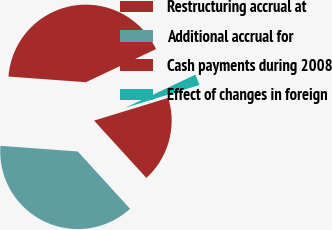Convert chart. <chart><loc_0><loc_0><loc_500><loc_500><pie_chart><fcel>Restructuring accrual at<fcel>Additional accrual for<fcel>Cash payments during 2008<fcel>Effect of changes in foreign<nl><fcel>41.81%<fcel>37.93%<fcel>17.97%<fcel>2.28%<nl></chart> 